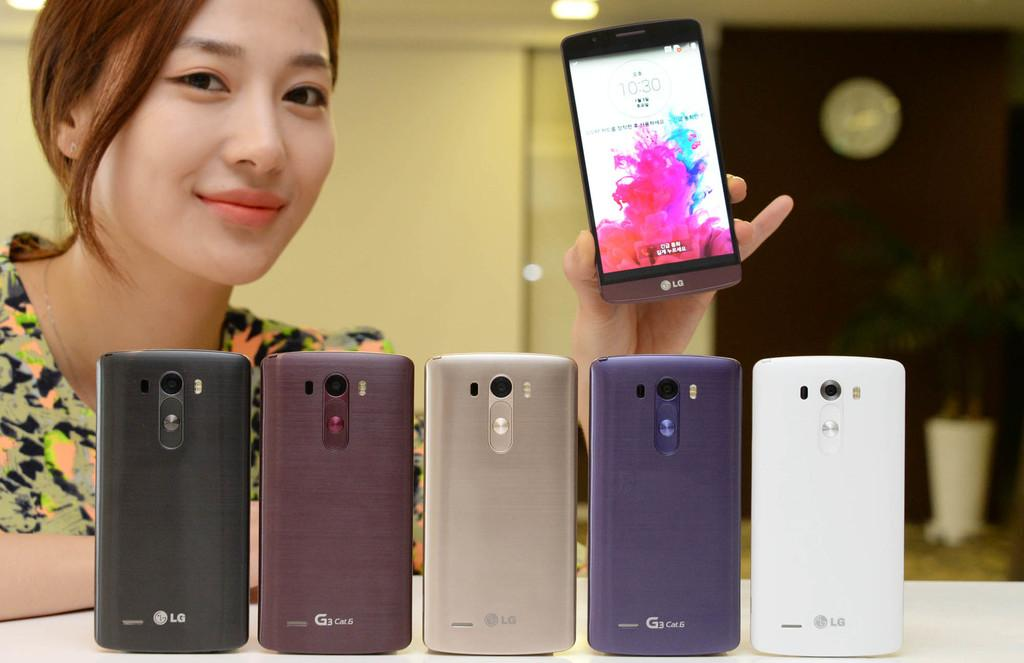Who is present in the image? There is a woman in the image. What is the woman holding? The woman is holding a mobile. What can be seen in the background of the image? There is a table in the image. What else can be found on the table? There are mobiles placed on the table. How does the woman plan to cross the bridge with her needle and improve her digestion in the image? There is no bridge, needle, or mention of digestion in the image. The image only features a woman holding a mobile and mobiles placed on a table. 